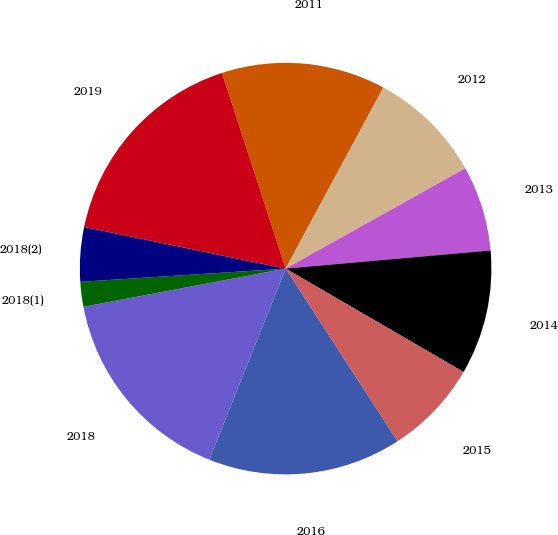Convert chart. <chart><loc_0><loc_0><loc_500><loc_500><pie_chart><fcel>2011<fcel>2012<fcel>2013<fcel>2014<fcel>2015<fcel>2016<fcel>2018<fcel>2018(1)<fcel>2018(2)<fcel>2019<nl><fcel>12.88%<fcel>9.02%<fcel>6.7%<fcel>9.79%<fcel>7.47%<fcel>15.2%<fcel>15.98%<fcel>1.95%<fcel>4.27%<fcel>16.75%<nl></chart> 